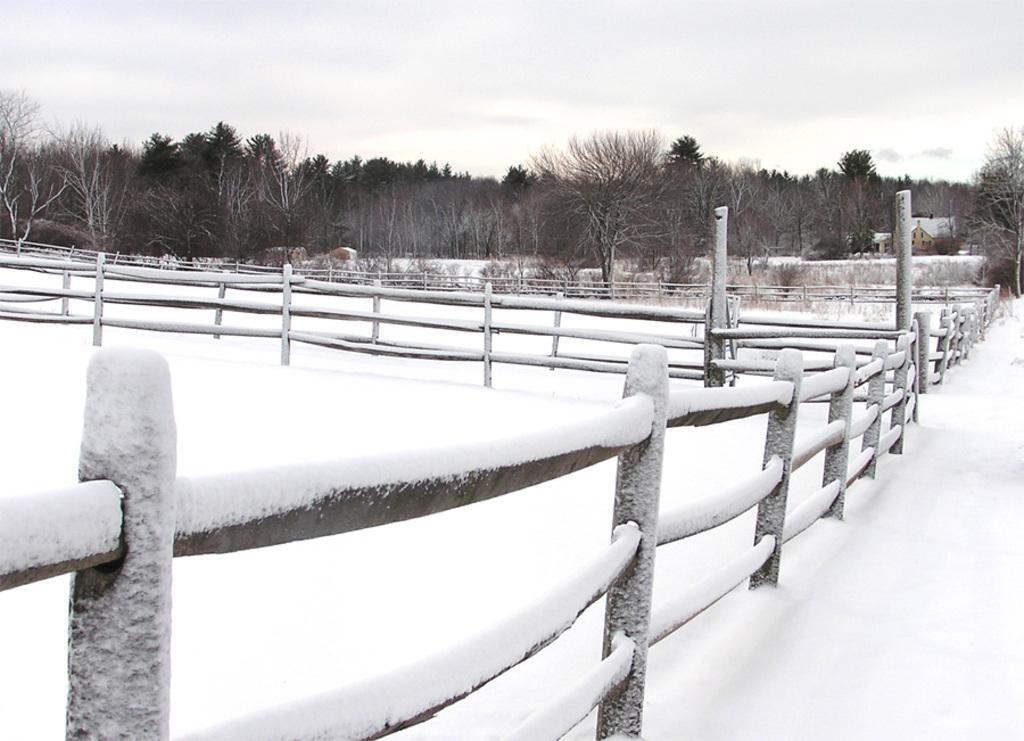In one or two sentences, can you explain what this image depicts? In this image we can see snow on the fences and ground. In the background there are trees, houses and clouds in the sky. 